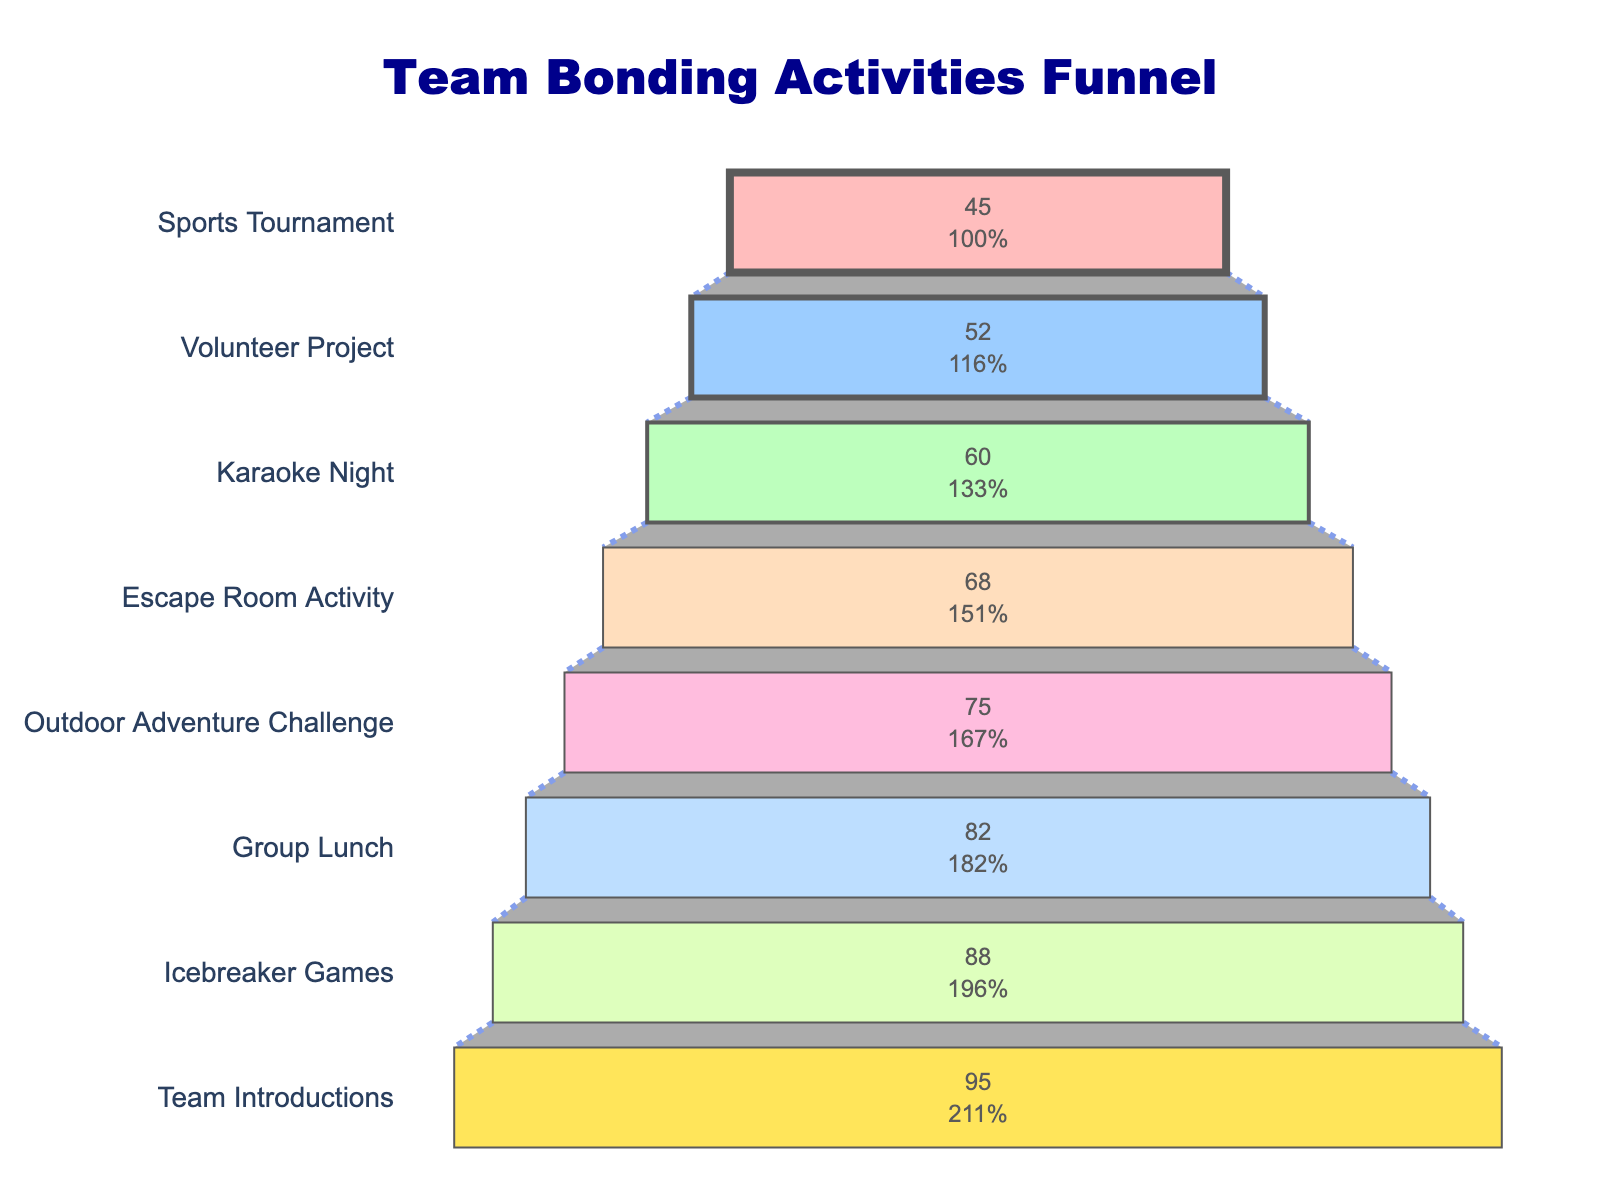What’s the title of the funnel chart? The title is located at the top of the chart, reading “Team Bonding Activities Funnel”.
Answer: Team Bonding Activities Funnel How many stages are displayed in the funnel? Count the number of labeled stages on the funnel chart. There are eight stages listed.
Answer: Eight Which stage has the highest participation rate? Look for the stage at the widest part of the funnel, which represents the highest participation rate. "Team Introductions" is at the top with 95%.
Answer: Team Introductions Which stage has the lowest participation rate? Look for the stage at the narrowest part of the funnel, which represents the lowest participation rate. "Sports Tournament" is at the lowest part with 45%.
Answer: Sports Tournament What percentage of the initial participation remains after the Icebreaker Games? Check the participation rate at Icebreaker Games, which is the second stage from the top, and then calculate the percentage of the initial 95%. (88/95) * 100 = 92.63%
Answer: 92.63% What’s the overall drop in participation rate from Team Introductions to Sports Tournament? Subtract the participation rate of Sports Tournament (45) from Team Introductions (95). 95 - 45 = 50
Answer: 50% Which stage shows the biggest decrease in participation compared to the previous stage? Compare the decrease in participation rate between consecutive stages. The largest decrease is from "Outdoor Adventure Challenge" (75) to "Escape Room Activity" (68), which is 7.
Answer: Outdoor Adventure Challenge to Escape Room Activity How does the participation rate at Escape Room Activity compare to Group Lunch? Compare the values for "Escape Room Activity" (68) and "Group Lunch" (82). 68 is lower than 82.
Answer: Escape Room Activity has a lower rate What is the participation rate difference between Karaoke Night and Volunteer Project? Subtract the rate of Volunteer Project (52) from Karaoke Night (60). 60 - 52 = 8
Answer: 8% What is the average participation rate across all stages? Add all participation rates: 95 + 88 + 82 + 75 + 68 + 60 + 52 + 45 = 565. Then divide by 8 (the number of stages). 565 / 8 ≈ 70.63
Answer: 70.63% 